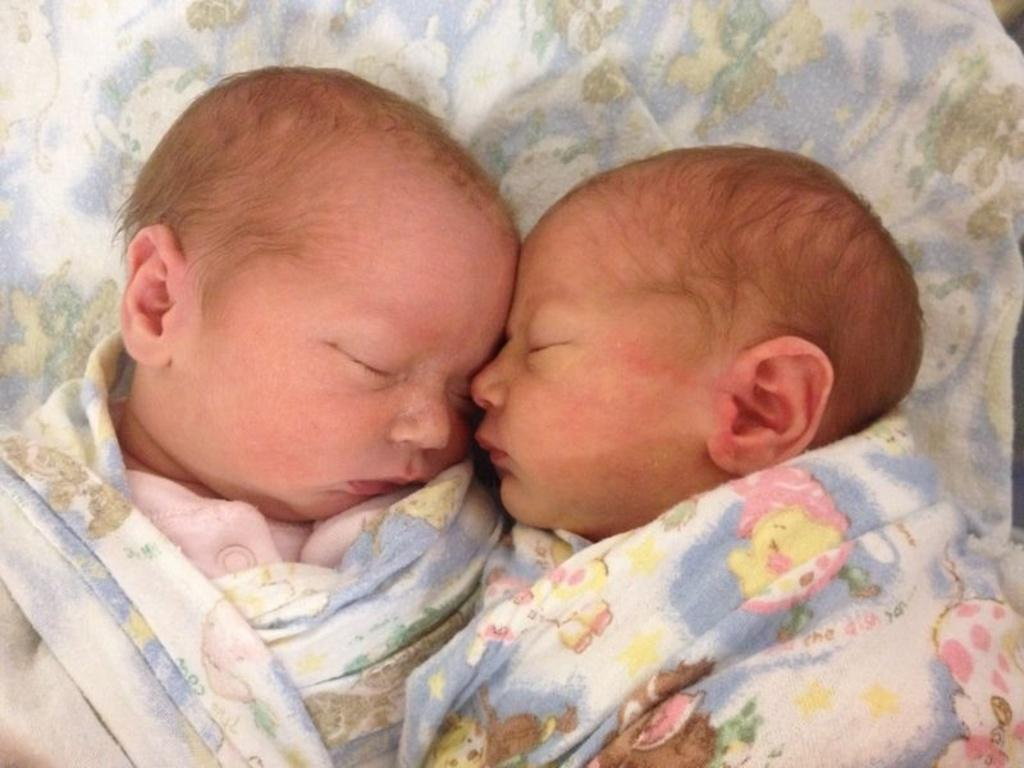How many children are present in the image? There are two kids in the image. What are the kids doing in the image? The kids are sleeping. Where are the kids located in the image? The kids are on a blanket. What type of lace is used to decorate the kids' party in the image? There is no party or lace present in the image; it features two kids sleeping on a blanket. How much debt do the kids owe after the party in the image? There is no party or debt mentioned in the image; it only shows the kids sleeping on a blanket. 